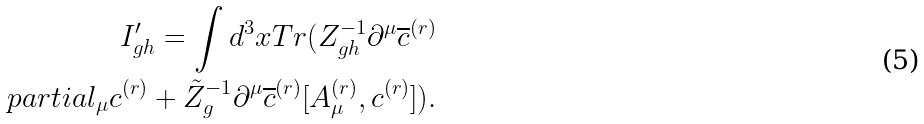Convert formula to latex. <formula><loc_0><loc_0><loc_500><loc_500>I _ { g h } ^ { \prime } = \int d ^ { 3 } x T r ( Z _ { g h } ^ { - 1 } \partial ^ { \mu } \overline { c } ^ { ( r ) } \\ p a r t i a l _ { \mu } c ^ { ( r ) } + \tilde { Z } _ { g } ^ { - 1 } \partial ^ { \mu } \overline { c } ^ { ( r ) } [ A ^ { ( r ) } _ { \mu } , c ^ { ( r ) } ] ) .</formula> 